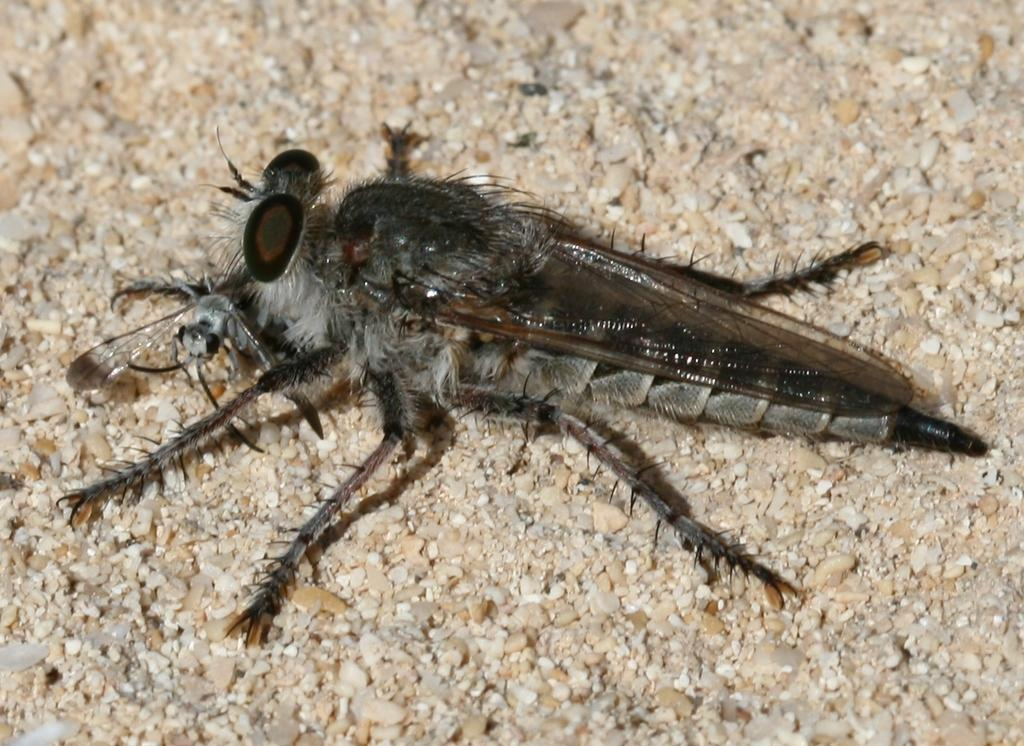What type of insect is in the image? There is a black color insect in the image. Where is the insect located in the image? The insect is on the ground. What type of pancake is the insect eating in the image? There is no pancake present in the image, and the insect is not shown eating anything. 